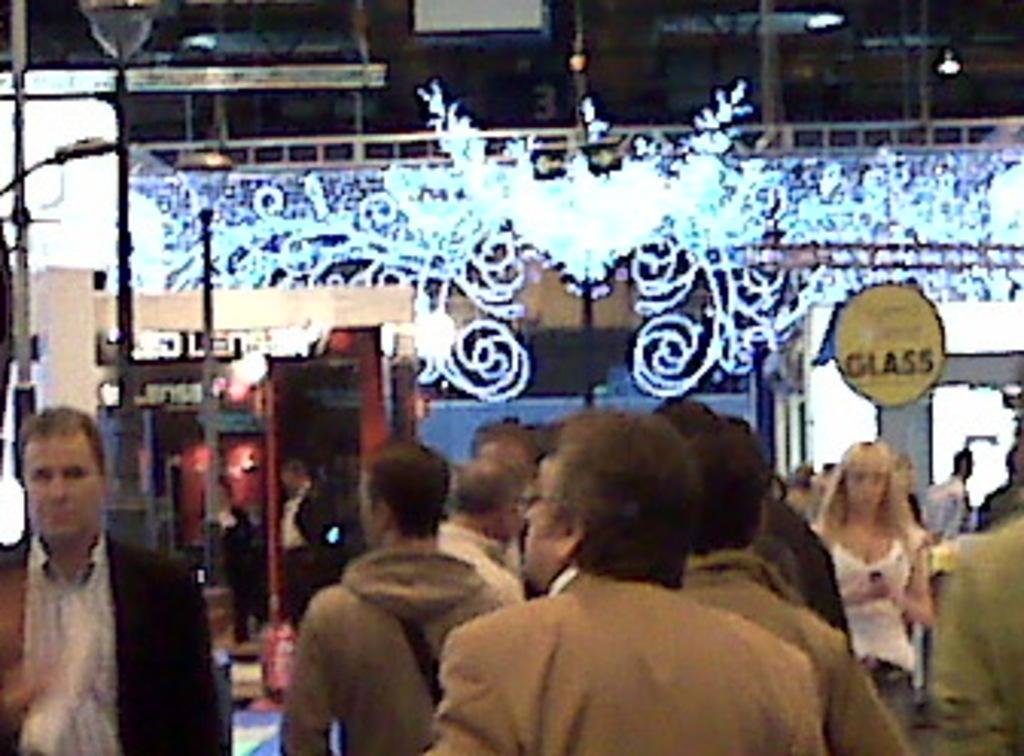Can you describe this image briefly? Here we can see group of people. There are poles, lights, and a board. There is a blur background. 